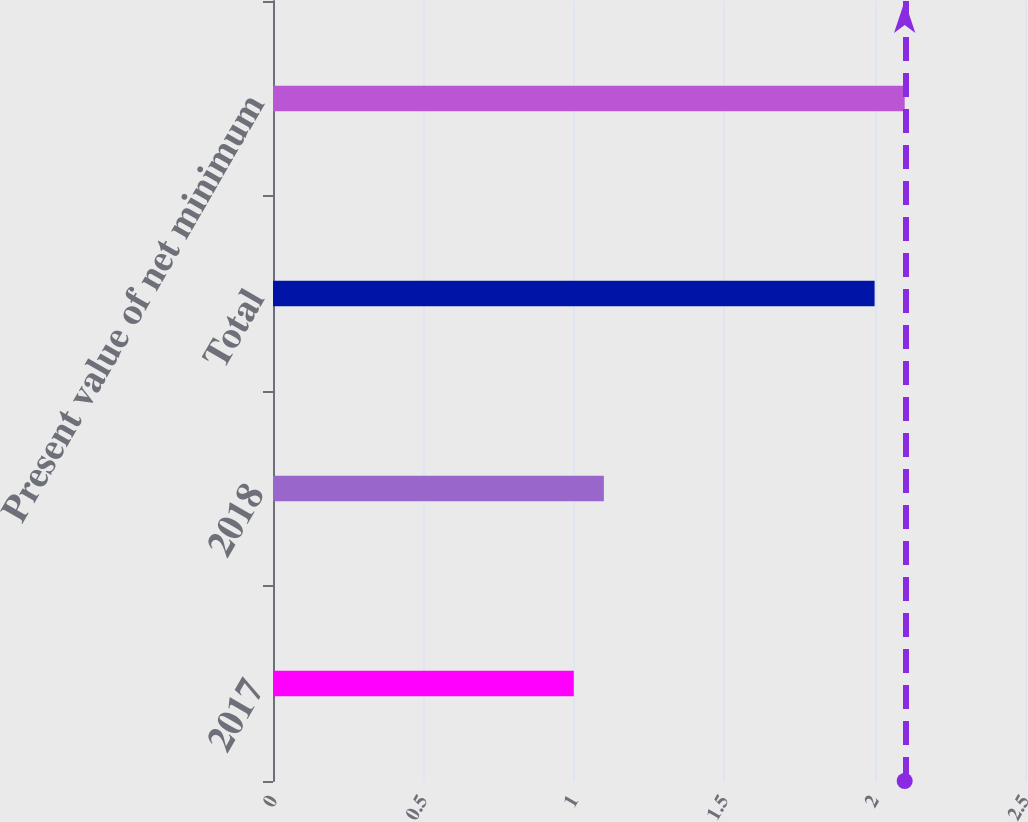Convert chart. <chart><loc_0><loc_0><loc_500><loc_500><bar_chart><fcel>2017<fcel>2018<fcel>Total<fcel>Present value of net minimum<nl><fcel>1<fcel>1.1<fcel>2<fcel>2.1<nl></chart> 